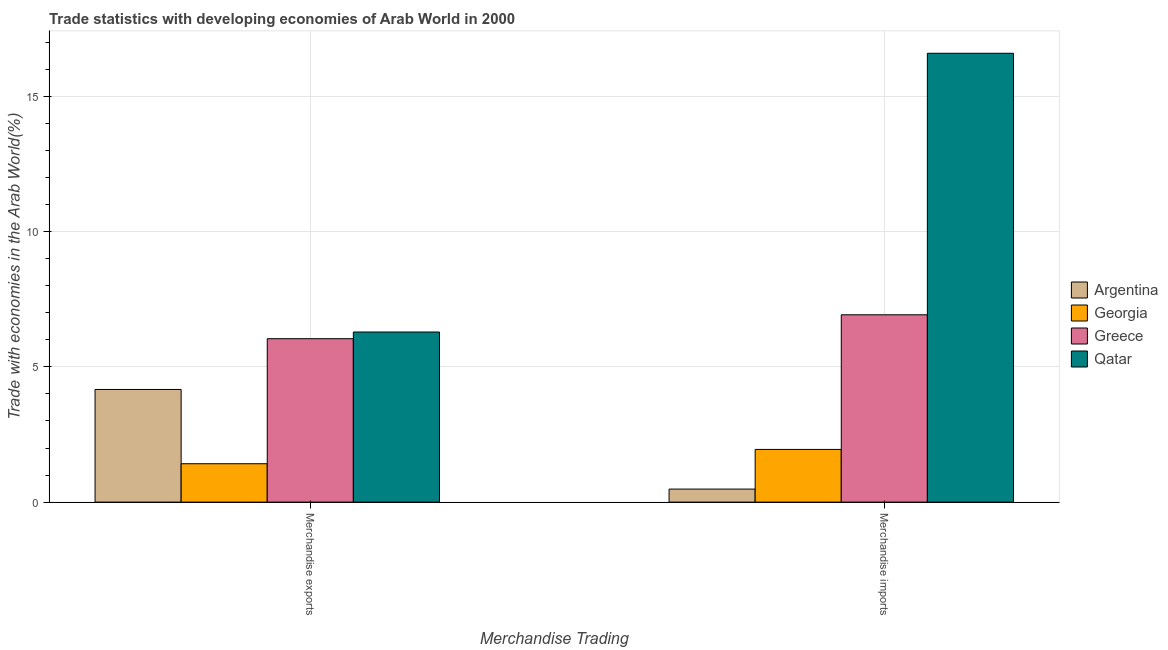How many different coloured bars are there?
Make the answer very short. 4. How many groups of bars are there?
Your answer should be compact. 2. Are the number of bars per tick equal to the number of legend labels?
Provide a short and direct response. Yes. Are the number of bars on each tick of the X-axis equal?
Keep it short and to the point. Yes. How many bars are there on the 1st tick from the left?
Provide a succinct answer. 4. How many bars are there on the 2nd tick from the right?
Offer a very short reply. 4. What is the merchandise imports in Georgia?
Offer a terse response. 1.95. Across all countries, what is the maximum merchandise exports?
Offer a terse response. 6.29. Across all countries, what is the minimum merchandise exports?
Your response must be concise. 1.42. In which country was the merchandise imports maximum?
Your answer should be compact. Qatar. What is the total merchandise imports in the graph?
Your response must be concise. 25.94. What is the difference between the merchandise exports in Argentina and that in Qatar?
Provide a short and direct response. -2.12. What is the difference between the merchandise imports in Qatar and the merchandise exports in Greece?
Ensure brevity in your answer.  10.55. What is the average merchandise imports per country?
Provide a succinct answer. 6.48. What is the difference between the merchandise exports and merchandise imports in Greece?
Give a very brief answer. -0.88. What is the ratio of the merchandise imports in Georgia to that in Greece?
Provide a short and direct response. 0.28. In how many countries, is the merchandise exports greater than the average merchandise exports taken over all countries?
Offer a very short reply. 2. What does the 1st bar from the left in Merchandise exports represents?
Ensure brevity in your answer.  Argentina. What is the difference between two consecutive major ticks on the Y-axis?
Your answer should be very brief. 5. Are the values on the major ticks of Y-axis written in scientific E-notation?
Offer a very short reply. No. Does the graph contain grids?
Your answer should be compact. Yes. Where does the legend appear in the graph?
Your answer should be compact. Center right. What is the title of the graph?
Your response must be concise. Trade statistics with developing economies of Arab World in 2000. What is the label or title of the X-axis?
Offer a very short reply. Merchandise Trading. What is the label or title of the Y-axis?
Provide a succinct answer. Trade with economies in the Arab World(%). What is the Trade with economies in the Arab World(%) in Argentina in Merchandise exports?
Make the answer very short. 4.16. What is the Trade with economies in the Arab World(%) of Georgia in Merchandise exports?
Make the answer very short. 1.42. What is the Trade with economies in the Arab World(%) in Greece in Merchandise exports?
Offer a very short reply. 6.04. What is the Trade with economies in the Arab World(%) of Qatar in Merchandise exports?
Make the answer very short. 6.29. What is the Trade with economies in the Arab World(%) in Argentina in Merchandise imports?
Provide a succinct answer. 0.48. What is the Trade with economies in the Arab World(%) in Georgia in Merchandise imports?
Make the answer very short. 1.95. What is the Trade with economies in the Arab World(%) in Greece in Merchandise imports?
Provide a succinct answer. 6.92. What is the Trade with economies in the Arab World(%) of Qatar in Merchandise imports?
Offer a terse response. 16.59. Across all Merchandise Trading, what is the maximum Trade with economies in the Arab World(%) in Argentina?
Ensure brevity in your answer.  4.16. Across all Merchandise Trading, what is the maximum Trade with economies in the Arab World(%) of Georgia?
Offer a very short reply. 1.95. Across all Merchandise Trading, what is the maximum Trade with economies in the Arab World(%) in Greece?
Your response must be concise. 6.92. Across all Merchandise Trading, what is the maximum Trade with economies in the Arab World(%) of Qatar?
Give a very brief answer. 16.59. Across all Merchandise Trading, what is the minimum Trade with economies in the Arab World(%) in Argentina?
Your answer should be compact. 0.48. Across all Merchandise Trading, what is the minimum Trade with economies in the Arab World(%) in Georgia?
Provide a short and direct response. 1.42. Across all Merchandise Trading, what is the minimum Trade with economies in the Arab World(%) of Greece?
Your answer should be compact. 6.04. Across all Merchandise Trading, what is the minimum Trade with economies in the Arab World(%) in Qatar?
Your answer should be compact. 6.29. What is the total Trade with economies in the Arab World(%) of Argentina in the graph?
Make the answer very short. 4.65. What is the total Trade with economies in the Arab World(%) of Georgia in the graph?
Make the answer very short. 3.37. What is the total Trade with economies in the Arab World(%) of Greece in the graph?
Offer a terse response. 12.96. What is the total Trade with economies in the Arab World(%) of Qatar in the graph?
Provide a short and direct response. 22.87. What is the difference between the Trade with economies in the Arab World(%) in Argentina in Merchandise exports and that in Merchandise imports?
Your answer should be very brief. 3.68. What is the difference between the Trade with economies in the Arab World(%) of Georgia in Merchandise exports and that in Merchandise imports?
Offer a very short reply. -0.53. What is the difference between the Trade with economies in the Arab World(%) in Greece in Merchandise exports and that in Merchandise imports?
Ensure brevity in your answer.  -0.88. What is the difference between the Trade with economies in the Arab World(%) of Qatar in Merchandise exports and that in Merchandise imports?
Keep it short and to the point. -10.3. What is the difference between the Trade with economies in the Arab World(%) of Argentina in Merchandise exports and the Trade with economies in the Arab World(%) of Georgia in Merchandise imports?
Your response must be concise. 2.22. What is the difference between the Trade with economies in the Arab World(%) of Argentina in Merchandise exports and the Trade with economies in the Arab World(%) of Greece in Merchandise imports?
Offer a terse response. -2.76. What is the difference between the Trade with economies in the Arab World(%) of Argentina in Merchandise exports and the Trade with economies in the Arab World(%) of Qatar in Merchandise imports?
Give a very brief answer. -12.42. What is the difference between the Trade with economies in the Arab World(%) of Georgia in Merchandise exports and the Trade with economies in the Arab World(%) of Greece in Merchandise imports?
Give a very brief answer. -5.5. What is the difference between the Trade with economies in the Arab World(%) in Georgia in Merchandise exports and the Trade with economies in the Arab World(%) in Qatar in Merchandise imports?
Offer a very short reply. -15.17. What is the difference between the Trade with economies in the Arab World(%) of Greece in Merchandise exports and the Trade with economies in the Arab World(%) of Qatar in Merchandise imports?
Keep it short and to the point. -10.55. What is the average Trade with economies in the Arab World(%) in Argentina per Merchandise Trading?
Your response must be concise. 2.32. What is the average Trade with economies in the Arab World(%) of Georgia per Merchandise Trading?
Give a very brief answer. 1.68. What is the average Trade with economies in the Arab World(%) of Greece per Merchandise Trading?
Your answer should be very brief. 6.48. What is the average Trade with economies in the Arab World(%) in Qatar per Merchandise Trading?
Keep it short and to the point. 11.44. What is the difference between the Trade with economies in the Arab World(%) of Argentina and Trade with economies in the Arab World(%) of Georgia in Merchandise exports?
Offer a very short reply. 2.74. What is the difference between the Trade with economies in the Arab World(%) of Argentina and Trade with economies in the Arab World(%) of Greece in Merchandise exports?
Offer a terse response. -1.88. What is the difference between the Trade with economies in the Arab World(%) of Argentina and Trade with economies in the Arab World(%) of Qatar in Merchandise exports?
Make the answer very short. -2.12. What is the difference between the Trade with economies in the Arab World(%) of Georgia and Trade with economies in the Arab World(%) of Greece in Merchandise exports?
Your response must be concise. -4.62. What is the difference between the Trade with economies in the Arab World(%) of Georgia and Trade with economies in the Arab World(%) of Qatar in Merchandise exports?
Provide a short and direct response. -4.87. What is the difference between the Trade with economies in the Arab World(%) of Greece and Trade with economies in the Arab World(%) of Qatar in Merchandise exports?
Provide a succinct answer. -0.25. What is the difference between the Trade with economies in the Arab World(%) of Argentina and Trade with economies in the Arab World(%) of Georgia in Merchandise imports?
Keep it short and to the point. -1.47. What is the difference between the Trade with economies in the Arab World(%) of Argentina and Trade with economies in the Arab World(%) of Greece in Merchandise imports?
Make the answer very short. -6.44. What is the difference between the Trade with economies in the Arab World(%) in Argentina and Trade with economies in the Arab World(%) in Qatar in Merchandise imports?
Offer a very short reply. -16.11. What is the difference between the Trade with economies in the Arab World(%) in Georgia and Trade with economies in the Arab World(%) in Greece in Merchandise imports?
Your answer should be very brief. -4.98. What is the difference between the Trade with economies in the Arab World(%) in Georgia and Trade with economies in the Arab World(%) in Qatar in Merchandise imports?
Provide a succinct answer. -14.64. What is the difference between the Trade with economies in the Arab World(%) in Greece and Trade with economies in the Arab World(%) in Qatar in Merchandise imports?
Provide a succinct answer. -9.66. What is the ratio of the Trade with economies in the Arab World(%) in Argentina in Merchandise exports to that in Merchandise imports?
Your response must be concise. 8.64. What is the ratio of the Trade with economies in the Arab World(%) of Georgia in Merchandise exports to that in Merchandise imports?
Ensure brevity in your answer.  0.73. What is the ratio of the Trade with economies in the Arab World(%) of Greece in Merchandise exports to that in Merchandise imports?
Provide a succinct answer. 0.87. What is the ratio of the Trade with economies in the Arab World(%) in Qatar in Merchandise exports to that in Merchandise imports?
Offer a very short reply. 0.38. What is the difference between the highest and the second highest Trade with economies in the Arab World(%) in Argentina?
Your answer should be compact. 3.68. What is the difference between the highest and the second highest Trade with economies in the Arab World(%) in Georgia?
Ensure brevity in your answer.  0.53. What is the difference between the highest and the second highest Trade with economies in the Arab World(%) in Greece?
Make the answer very short. 0.88. What is the difference between the highest and the second highest Trade with economies in the Arab World(%) of Qatar?
Provide a short and direct response. 10.3. What is the difference between the highest and the lowest Trade with economies in the Arab World(%) in Argentina?
Provide a succinct answer. 3.68. What is the difference between the highest and the lowest Trade with economies in the Arab World(%) of Georgia?
Give a very brief answer. 0.53. What is the difference between the highest and the lowest Trade with economies in the Arab World(%) in Greece?
Your answer should be very brief. 0.88. What is the difference between the highest and the lowest Trade with economies in the Arab World(%) in Qatar?
Give a very brief answer. 10.3. 